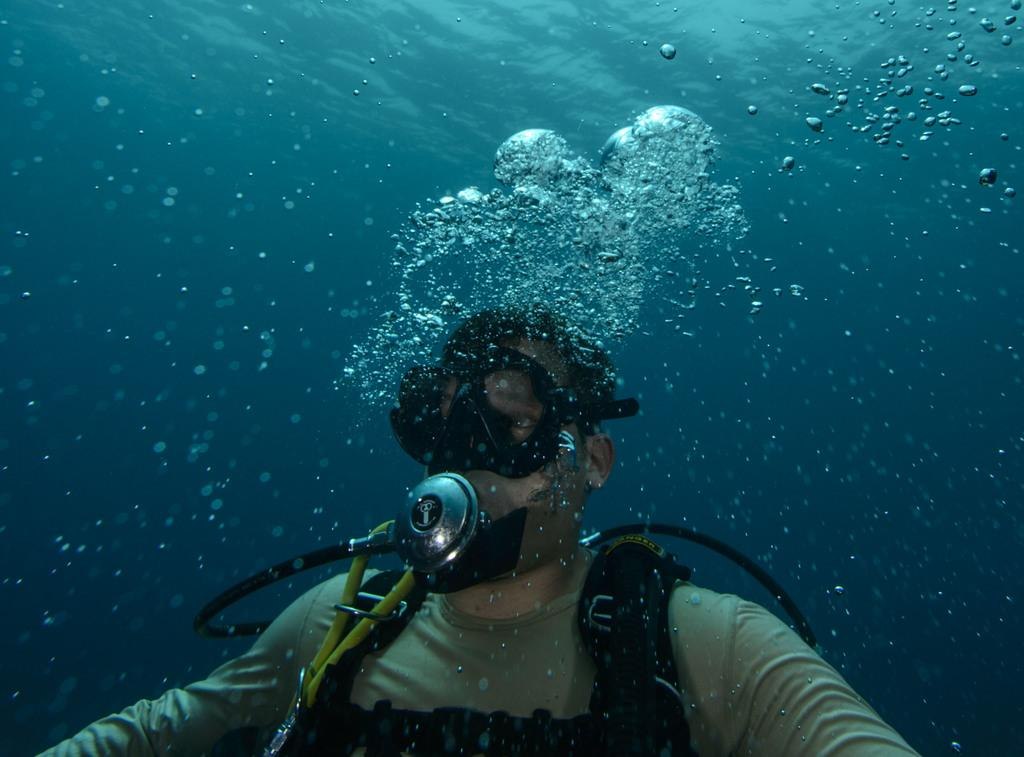What is the main setting of the image? There is an ocean in the image. What is the person in the image doing? There is a person swimming in the ocean. Can you describe the person's attire in the image? The person is wearing a costume. How does the person in the image sort the items on the board? There is no board or sorting activity present in the image; it features a person swimming in the ocean while wearing a costume. What is the person's reaction to the sneeze in the image? There is no sneeze or reaction to a sneeze present in the image; it features a person swimming in the ocean while wearing a costume. 